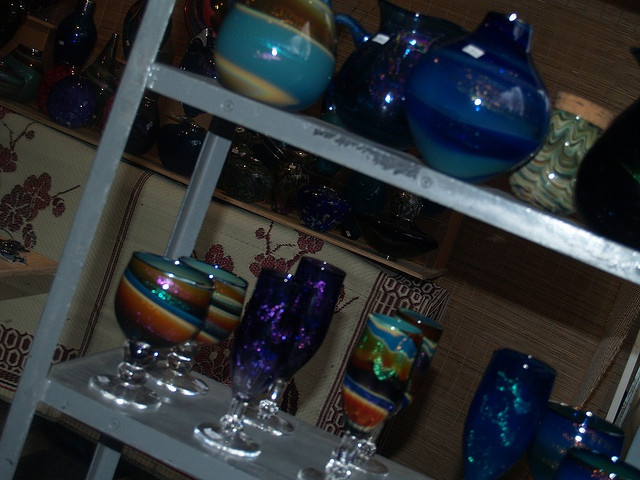Describe the objects in this image and their specific colors. I can see vase in black, navy, blue, and gray tones, wine glass in black, maroon, gray, and darkblue tones, vase in black, teal, gray, and darkblue tones, vase in black, navy, darkgray, and blue tones, and wine glass in black, gray, navy, and darkblue tones in this image. 